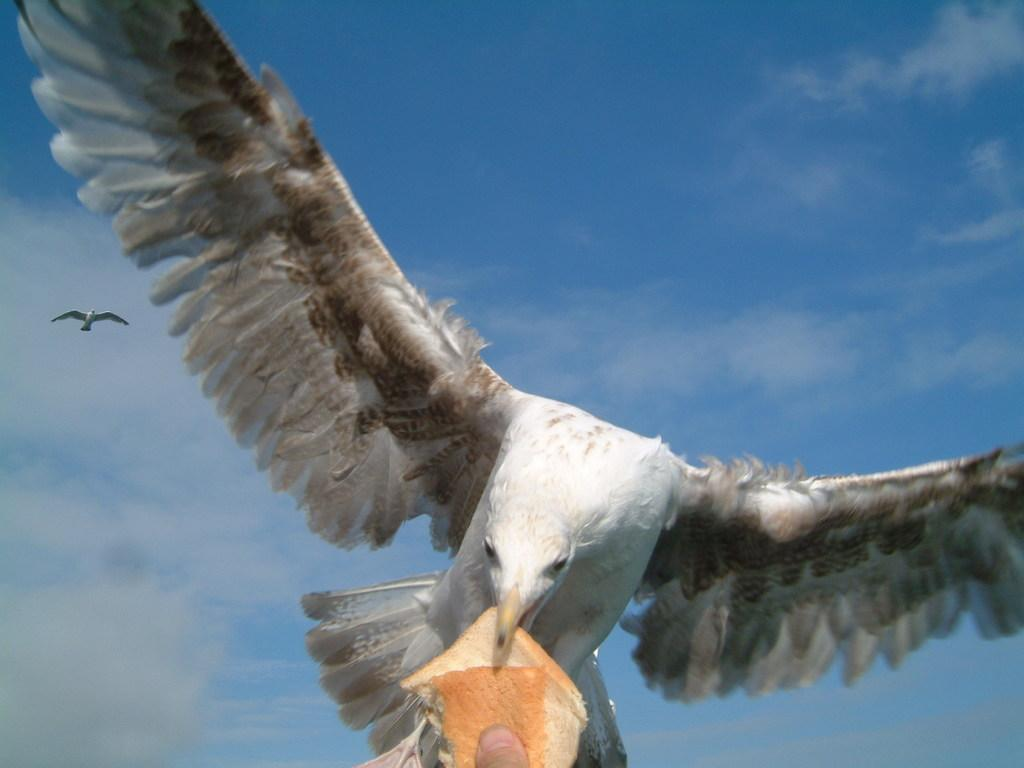What animal is in the front of the image? There is a bird in the front of the image. What is the person holding in the image? The person is holding bread in the image. Can you describe the bird that is flying in the image? There is another bird flying in the sky in the image. What can be seen in the background of the image? The sky is visible in the background of the image. Where is the donkey located in the image? There is no donkey present in the image. Can you tell me what type of store is visible in the image? There is no store present in the image. 